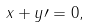Convert formula to latex. <formula><loc_0><loc_0><loc_500><loc_500>x + y \prime = 0 ,</formula> 